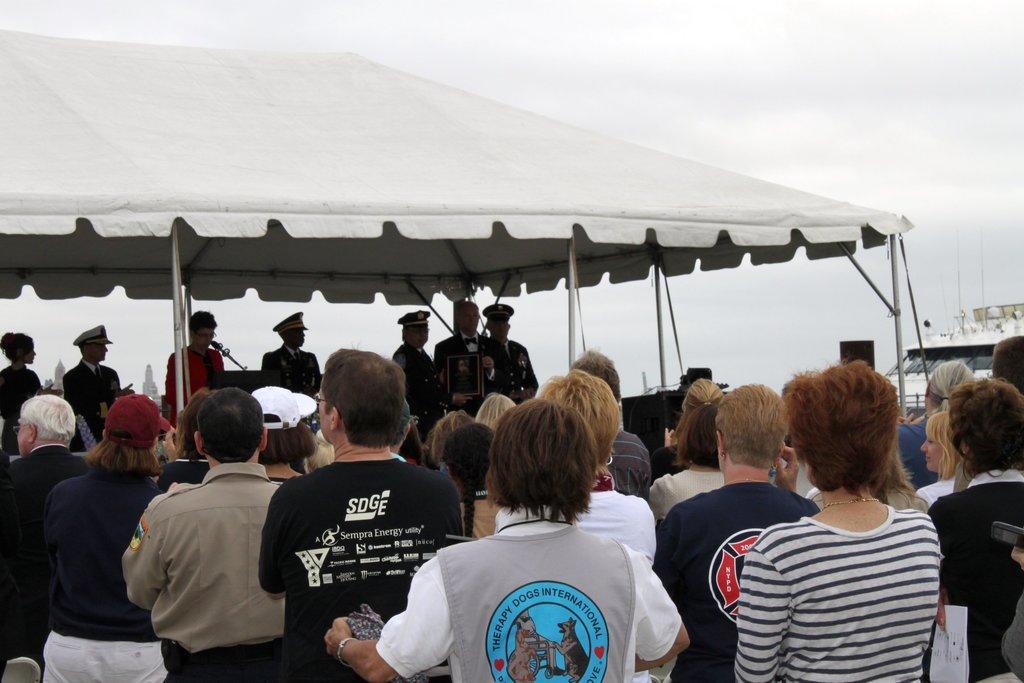Could you give a brief overview of what you see in this image? In this image, we can see a group of people standing. In the background, we can see a group of people standing under the tent. In the middle of the image, we can see a person wearing a red color shirt is standing in front of the podium, on the podium, we can see a microphone. On the right side, we can see a building, speakers. At the top, we can see a sky which is cloudy. 